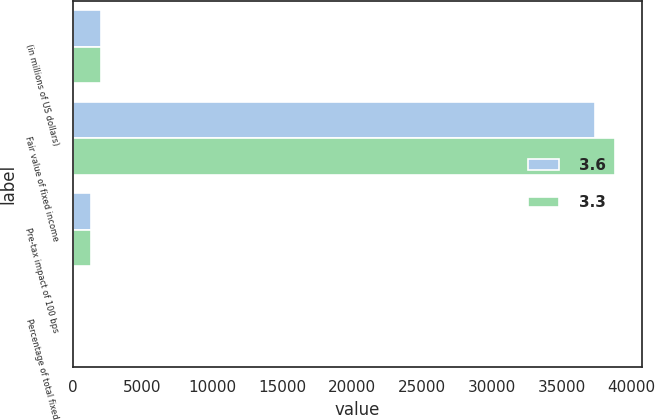<chart> <loc_0><loc_0><loc_500><loc_500><stacked_bar_chart><ecel><fcel>(in millions of US dollars)<fcel>Fair value of fixed income<fcel>Pre-tax impact of 100 bps<fcel>Percentage of total fixed<nl><fcel>3.6<fcel>2008<fcel>37370<fcel>1329<fcel>3.6<nl><fcel>3.3<fcel>2007<fcel>38830<fcel>1281<fcel>3.3<nl></chart> 